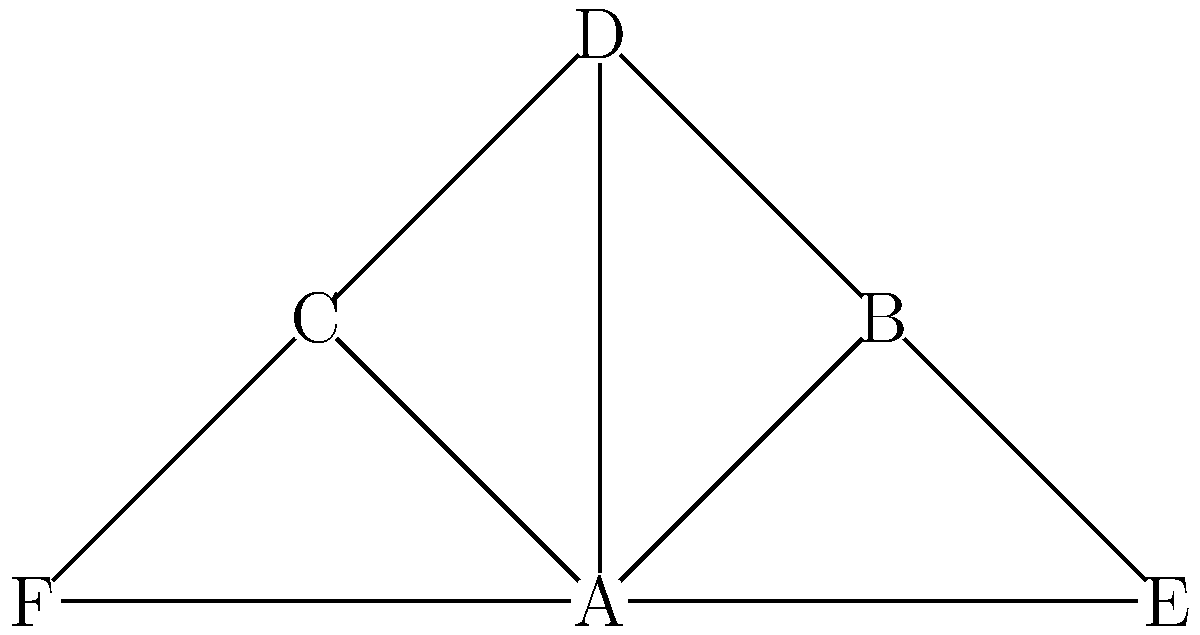In the disease transmission network shown above, which node would be considered the most critical for controlling the spread of the disease, based on its centrality and connectivity? Justify your answer using relevant network analysis concepts. To identify the most critical node in this disease transmission network, we need to consider several factors:

1. Degree centrality: This measures the number of direct connections a node has.
   Node A has 5 connections, while others have 2 or 3.

2. Betweenness centrality: This measures how often a node acts as a bridge along the shortest path between two other nodes.
   Node A appears in most shortest paths between other nodes.

3. Closeness centrality: This measures how close a node is to all other nodes in the network.
   Node A has the shortest average path length to all other nodes.

4. Network topology: The graph shows a star-like structure with Node A at the center.

5. Potential for disease spread: Removing Node A would disconnect the network into smaller components, significantly reducing the potential for widespread transmission.

Given these considerations:

1. Node A has the highest degree centrality (5 connections).
2. It likely has the highest betweenness centrality as it connects all other nodes.
3. It has the highest closeness centrality, being directly connected to all other nodes.
4. Its central position in the star topology makes it a critical point for disease transmission.
5. Removing Node A would most effectively disrupt the disease spread in this network.

Therefore, Node A is the most critical for controlling the spread of the disease in this network.
Answer: Node A 